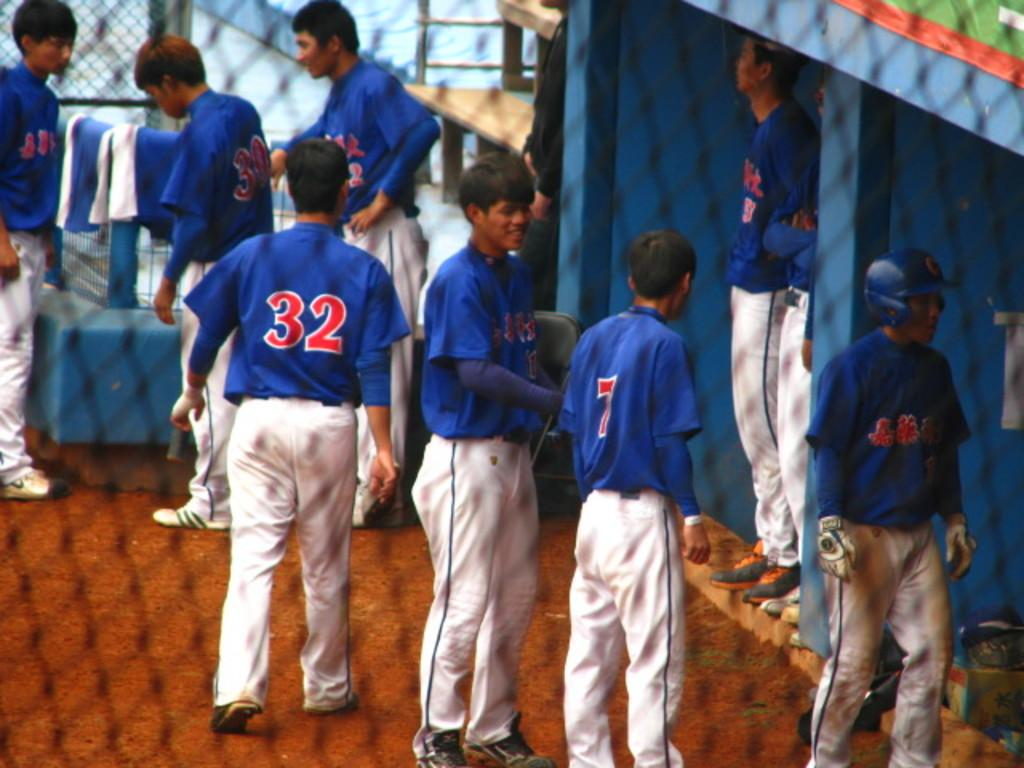<image>
Relay a brief, clear account of the picture shown. a few players and one with the number 32 on their back 